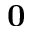<formula> <loc_0><loc_0><loc_500><loc_500>0</formula> 